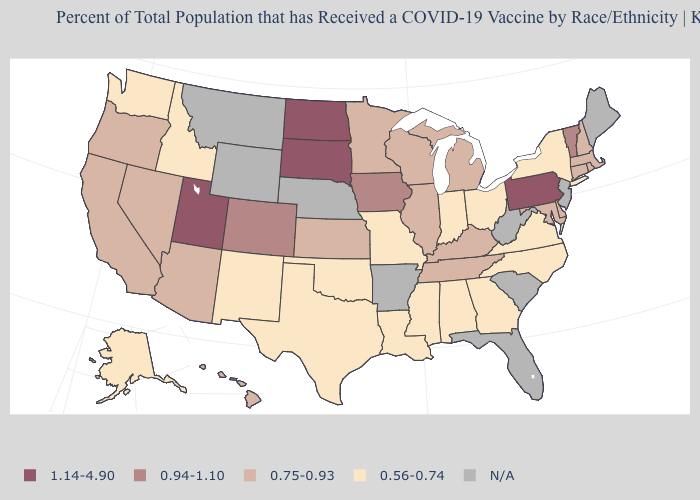How many symbols are there in the legend?
Answer briefly. 5. Name the states that have a value in the range N/A?
Keep it brief. Arkansas, Florida, Maine, Montana, Nebraska, New Jersey, South Carolina, West Virginia, Wyoming. What is the value of Arizona?
Short answer required. 0.75-0.93. Among the states that border Virginia , does North Carolina have the lowest value?
Give a very brief answer. Yes. Name the states that have a value in the range N/A?
Short answer required. Arkansas, Florida, Maine, Montana, Nebraska, New Jersey, South Carolina, West Virginia, Wyoming. Name the states that have a value in the range N/A?
Short answer required. Arkansas, Florida, Maine, Montana, Nebraska, New Jersey, South Carolina, West Virginia, Wyoming. Name the states that have a value in the range 0.56-0.74?
Quick response, please. Alabama, Alaska, Georgia, Idaho, Indiana, Louisiana, Mississippi, Missouri, New Mexico, New York, North Carolina, Ohio, Oklahoma, Texas, Virginia, Washington. Name the states that have a value in the range N/A?
Be succinct. Arkansas, Florida, Maine, Montana, Nebraska, New Jersey, South Carolina, West Virginia, Wyoming. What is the value of Idaho?
Short answer required. 0.56-0.74. What is the value of West Virginia?
Give a very brief answer. N/A. What is the value of Colorado?
Give a very brief answer. 0.94-1.10. What is the value of New Mexico?
Quick response, please. 0.56-0.74. How many symbols are there in the legend?
Quick response, please. 5. What is the highest value in the West ?
Keep it brief. 1.14-4.90. What is the value of Kansas?
Short answer required. 0.75-0.93. 